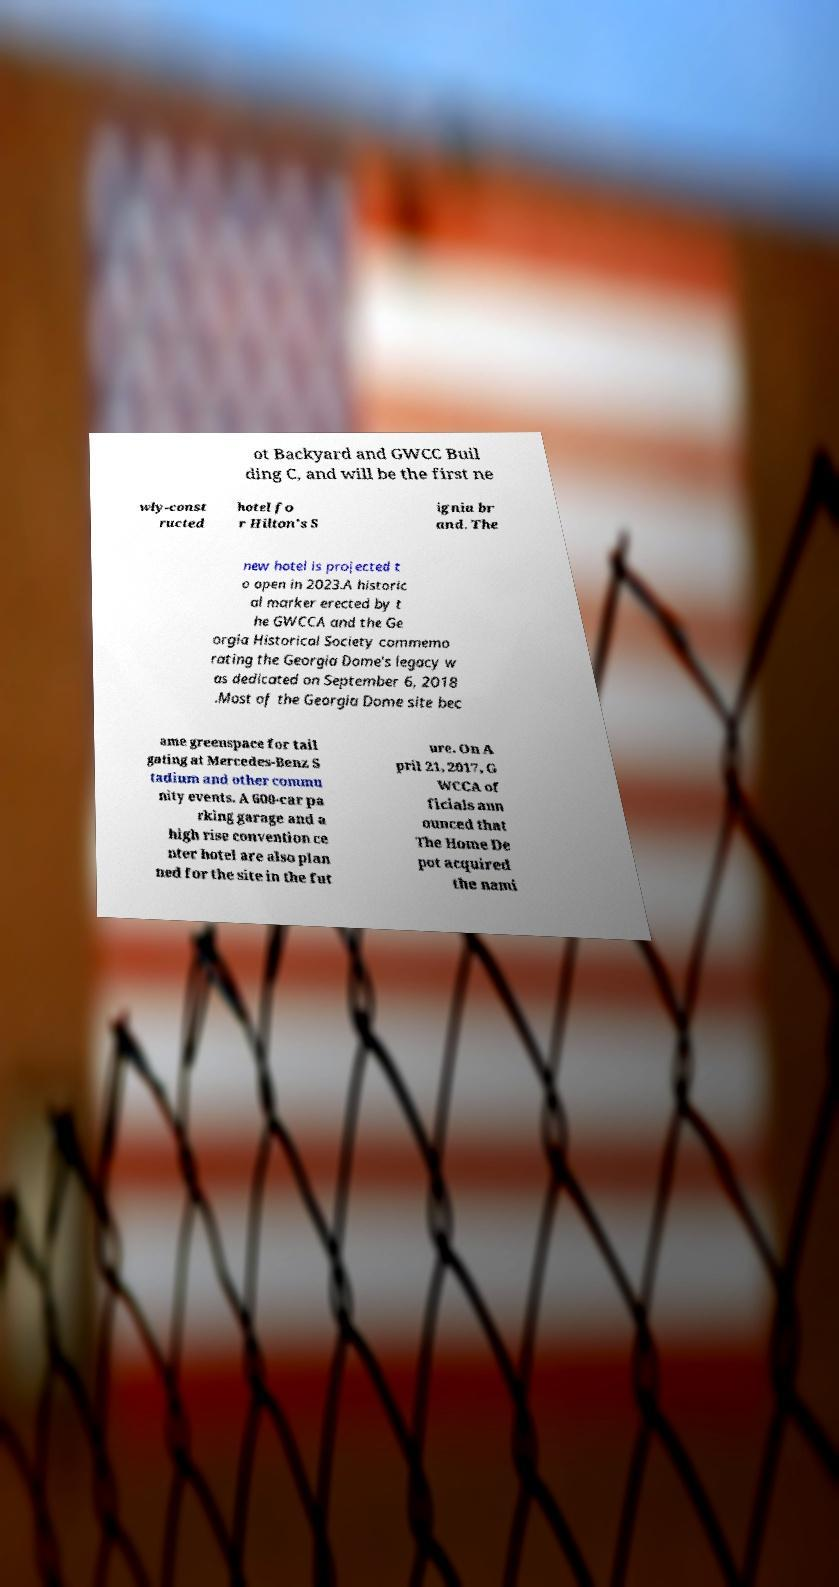I need the written content from this picture converted into text. Can you do that? ot Backyard and GWCC Buil ding C, and will be the first ne wly-const ructed hotel fo r Hilton's S ignia br and. The new hotel is projected t o open in 2023.A historic al marker erected by t he GWCCA and the Ge orgia Historical Society commemo rating the Georgia Dome's legacy w as dedicated on September 6, 2018 .Most of the Georgia Dome site bec ame greenspace for tail gating at Mercedes-Benz S tadium and other commu nity events. A 600-car pa rking garage and a high rise convention ce nter hotel are also plan ned for the site in the fut ure. On A pril 21, 2017, G WCCA of ficials ann ounced that The Home De pot acquired the nami 